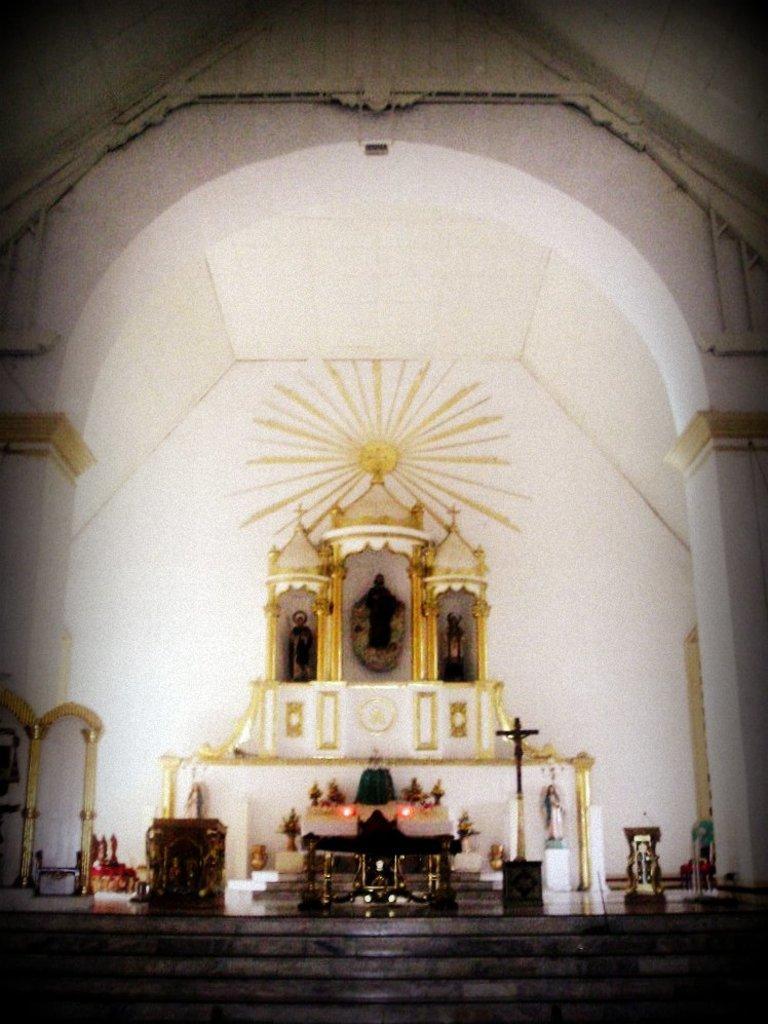Describe this image in one or two sentences. This is an inside image of a church , where there is arch, stair case, sculptures, holy cross symbol, table, chairs, flower bouquets and some items. 